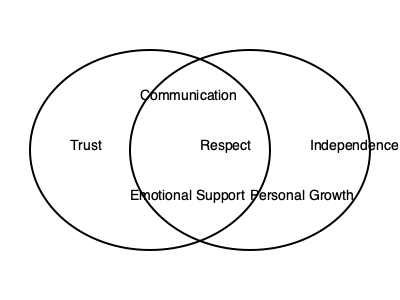Based on the Venn diagram illustrating qualities in healthy relationships, which characteristic is shared between both circles and represents a fundamental aspect of equality in dating? To answer this question, we need to analyze the Venn diagram and understand the significance of the qualities represented:

1. The diagram shows two intersecting circles, each representing qualities in healthy relationships.

2. The qualities listed are:
   - Trust (left circle)
   - Communication (overlapping area)
   - Respect (overlapping area)
   - Independence (right circle)
   - Emotional Support (left circle)
   - Personal Growth (right circle)

3. The qualities in the overlapping area are shared between both circles, indicating they are common to both aspects of healthy relationships.

4. The question asks for a characteristic that is shared and represents equality in dating.

5. Of the shared qualities, "Respect" aligns most closely with the concept of equality in relationships.

6. Respect implies treating each partner as an equal, valuing their opinions, and acknowledging their worth, which is fundamental to equality in dating.

Therefore, the characteristic that is shared between both circles and represents a fundamental aspect of equality in dating is Respect.
Answer: Respect 